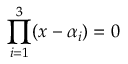Convert formula to latex. <formula><loc_0><loc_0><loc_500><loc_500>\prod _ { i = 1 } ^ { 3 } ( x - \alpha _ { i } ) = 0</formula> 